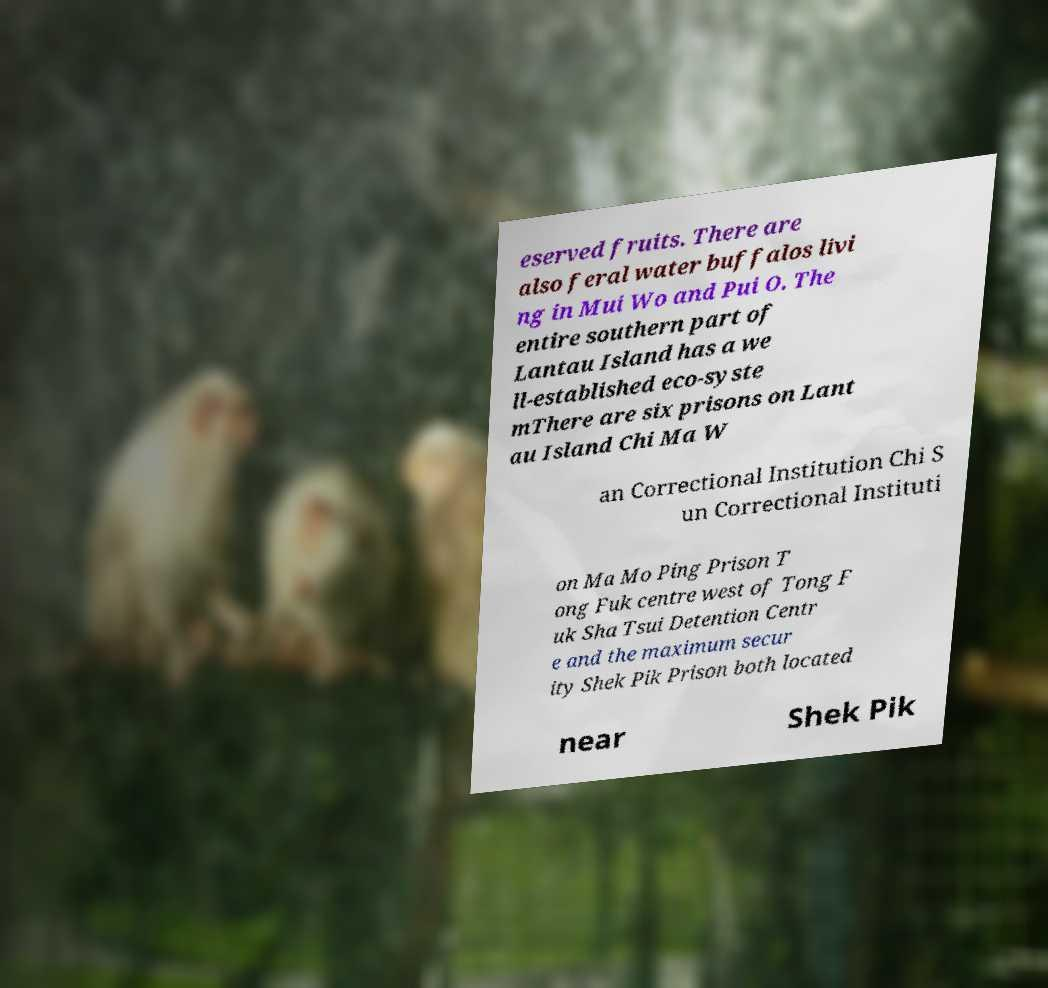Could you extract and type out the text from this image? eserved fruits. There are also feral water buffalos livi ng in Mui Wo and Pui O. The entire southern part of Lantau Island has a we ll-established eco-syste mThere are six prisons on Lant au Island Chi Ma W an Correctional Institution Chi S un Correctional Instituti on Ma Mo Ping Prison T ong Fuk centre west of Tong F uk Sha Tsui Detention Centr e and the maximum secur ity Shek Pik Prison both located near Shek Pik 